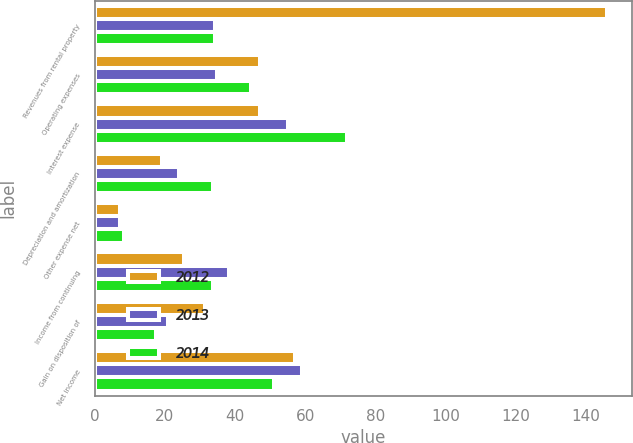Convert chart. <chart><loc_0><loc_0><loc_500><loc_500><stacked_bar_chart><ecel><fcel>Revenues from rental property<fcel>Operating expenses<fcel>Interest expense<fcel>Depreciation and amortization<fcel>Other expense net<fcel>Income from continuing<fcel>Gain on disposition of<fcel>Net income<nl><fcel>2012<fcel>146<fcel>47<fcel>47.1<fcel>19.2<fcel>7.2<fcel>25.5<fcel>31.5<fcel>57<nl><fcel>2013<fcel>34.25<fcel>34.8<fcel>55.2<fcel>24<fcel>7.1<fcel>38.4<fcel>20.8<fcel>59.2<nl><fcel>2014<fcel>34.25<fcel>44.7<fcel>72<fcel>33.7<fcel>8.3<fcel>33.6<fcel>17.5<fcel>51.1<nl></chart> 